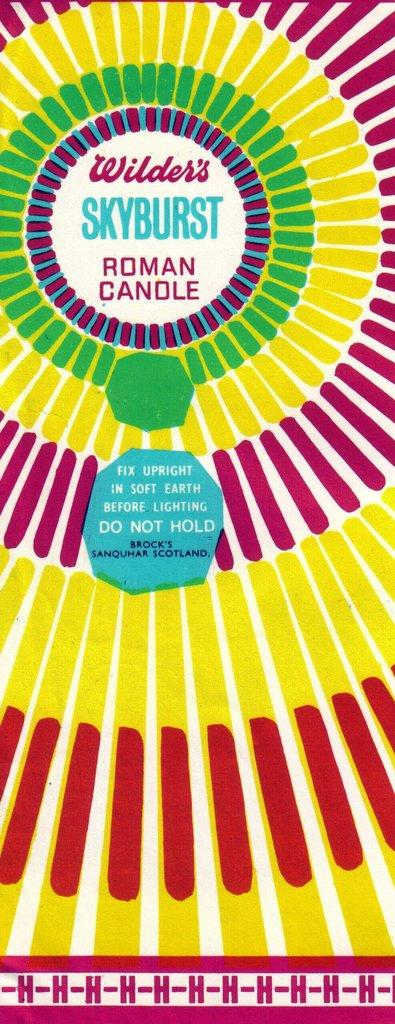<image>
Give a short and clear explanation of the subsequent image. A ring of colors with Wilder's Skyburst Roman Candle in the middle of it. 